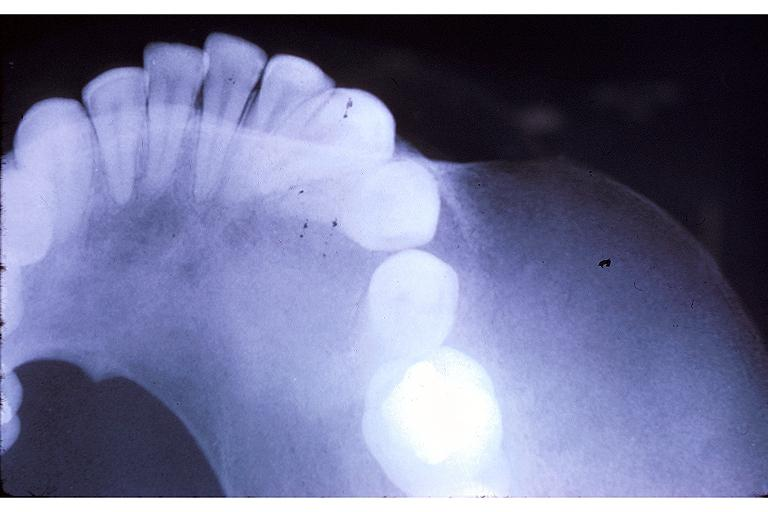s oral present?
Answer the question using a single word or phrase. Yes 